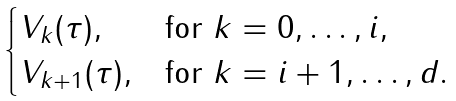<formula> <loc_0><loc_0><loc_500><loc_500>\begin{cases} V _ { k } ( \tau ) , & \text {for $k = 0,\dots,i$} , \\ V _ { k + 1 } ( \tau ) , & \text {for $k = i+1,\dots,d$} . \end{cases}</formula> 